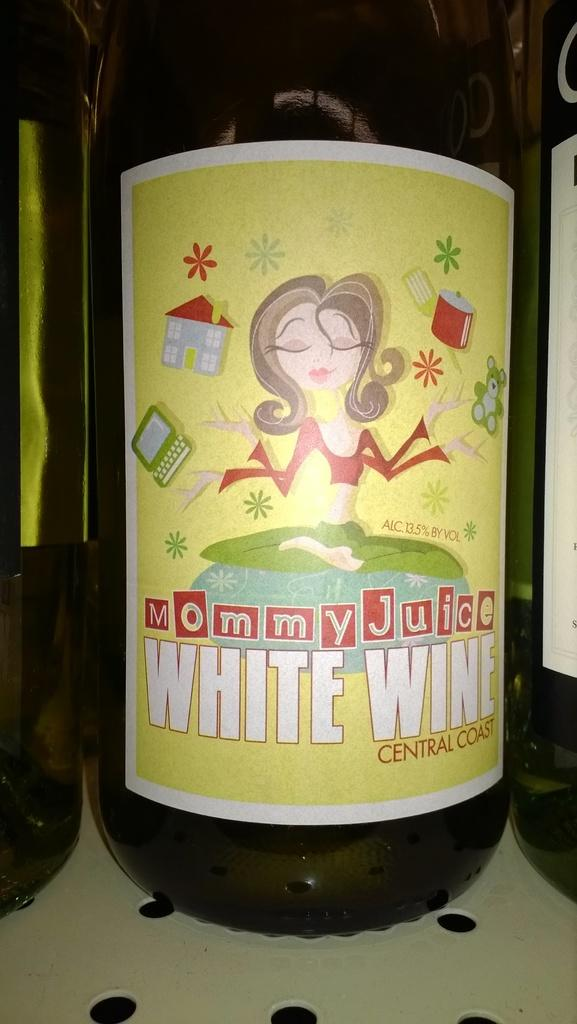<image>
Render a clear and concise summary of the photo. the name is white wine and a lady is on the cover 